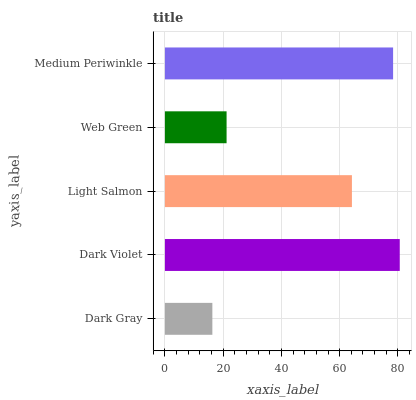Is Dark Gray the minimum?
Answer yes or no. Yes. Is Dark Violet the maximum?
Answer yes or no. Yes. Is Light Salmon the minimum?
Answer yes or no. No. Is Light Salmon the maximum?
Answer yes or no. No. Is Dark Violet greater than Light Salmon?
Answer yes or no. Yes. Is Light Salmon less than Dark Violet?
Answer yes or no. Yes. Is Light Salmon greater than Dark Violet?
Answer yes or no. No. Is Dark Violet less than Light Salmon?
Answer yes or no. No. Is Light Salmon the high median?
Answer yes or no. Yes. Is Light Salmon the low median?
Answer yes or no. Yes. Is Medium Periwinkle the high median?
Answer yes or no. No. Is Dark Violet the low median?
Answer yes or no. No. 